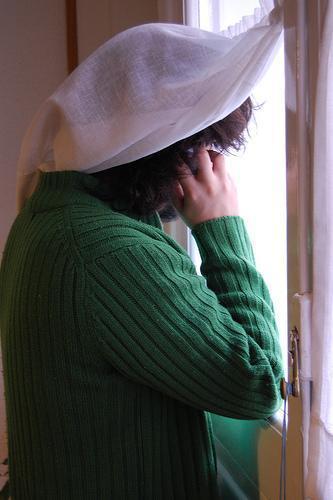How many people are there?
Give a very brief answer. 1. 